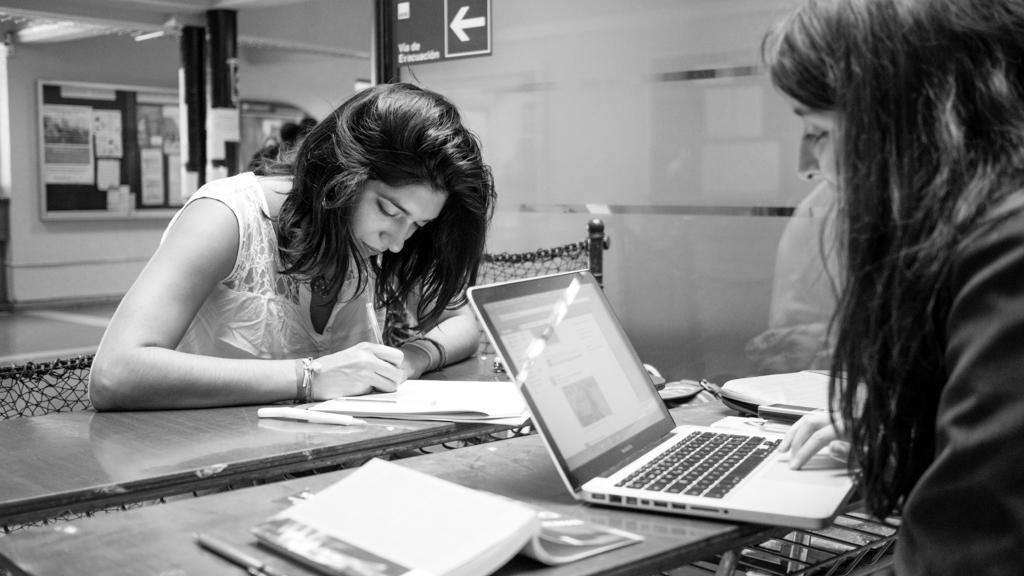Can you describe this image briefly? This is a black and white image. There are tables and people are sitting in tables. There is a board on the left side. On the tables there are books, laptops, papers. 